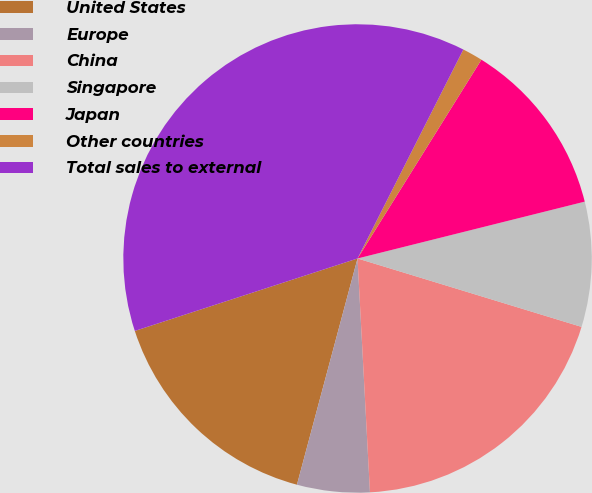Convert chart to OTSL. <chart><loc_0><loc_0><loc_500><loc_500><pie_chart><fcel>United States<fcel>Europe<fcel>China<fcel>Singapore<fcel>Japan<fcel>Other countries<fcel>Total sales to external<nl><fcel>15.83%<fcel>5.01%<fcel>19.44%<fcel>8.62%<fcel>12.23%<fcel>1.41%<fcel>37.47%<nl></chart> 